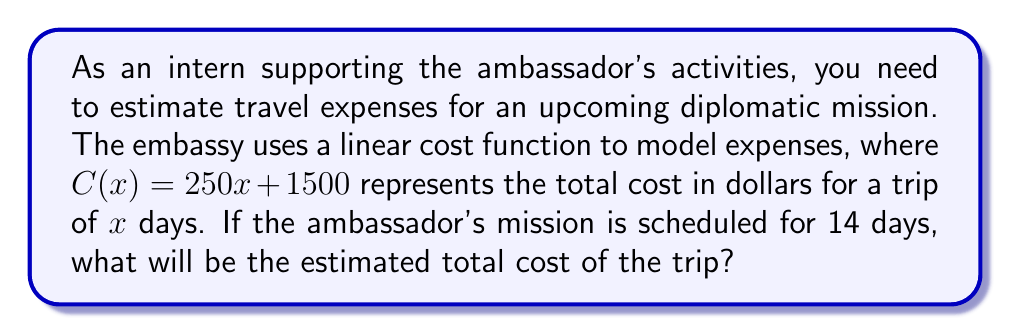Show me your answer to this math problem. To solve this problem, we need to use the given linear cost function and substitute the number of days into the equation. Let's break it down step-by-step:

1. The linear cost function is given as:
   $$C(x) = 250x + 1500$$
   Where $C(x)$ is the total cost in dollars, and $x$ is the number of days.

2. We are told that the ambassador's mission is scheduled for 14 days, so we need to substitute $x = 14$ into the equation:
   $$C(14) = 250(14) + 1500$$

3. Let's calculate the first term:
   $$250(14) = 3500$$

4. Now, we can substitute this value back into the equation:
   $$C(14) = 3500 + 1500$$

5. Finally, we add these numbers to get the total estimated cost:
   $$C(14) = 5000$$

Therefore, the estimated total cost for the 14-day diplomatic mission is $5,000.
Answer: $5,000 